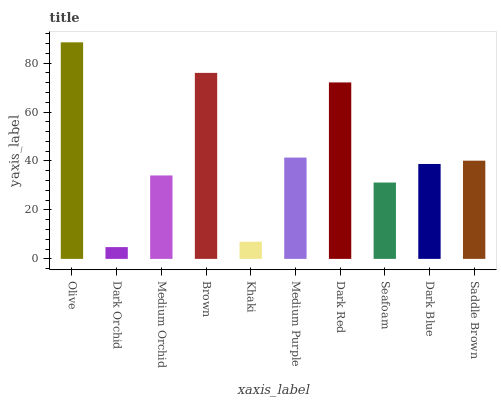Is Dark Orchid the minimum?
Answer yes or no. Yes. Is Olive the maximum?
Answer yes or no. Yes. Is Medium Orchid the minimum?
Answer yes or no. No. Is Medium Orchid the maximum?
Answer yes or no. No. Is Medium Orchid greater than Dark Orchid?
Answer yes or no. Yes. Is Dark Orchid less than Medium Orchid?
Answer yes or no. Yes. Is Dark Orchid greater than Medium Orchid?
Answer yes or no. No. Is Medium Orchid less than Dark Orchid?
Answer yes or no. No. Is Saddle Brown the high median?
Answer yes or no. Yes. Is Dark Blue the low median?
Answer yes or no. Yes. Is Khaki the high median?
Answer yes or no. No. Is Dark Orchid the low median?
Answer yes or no. No. 